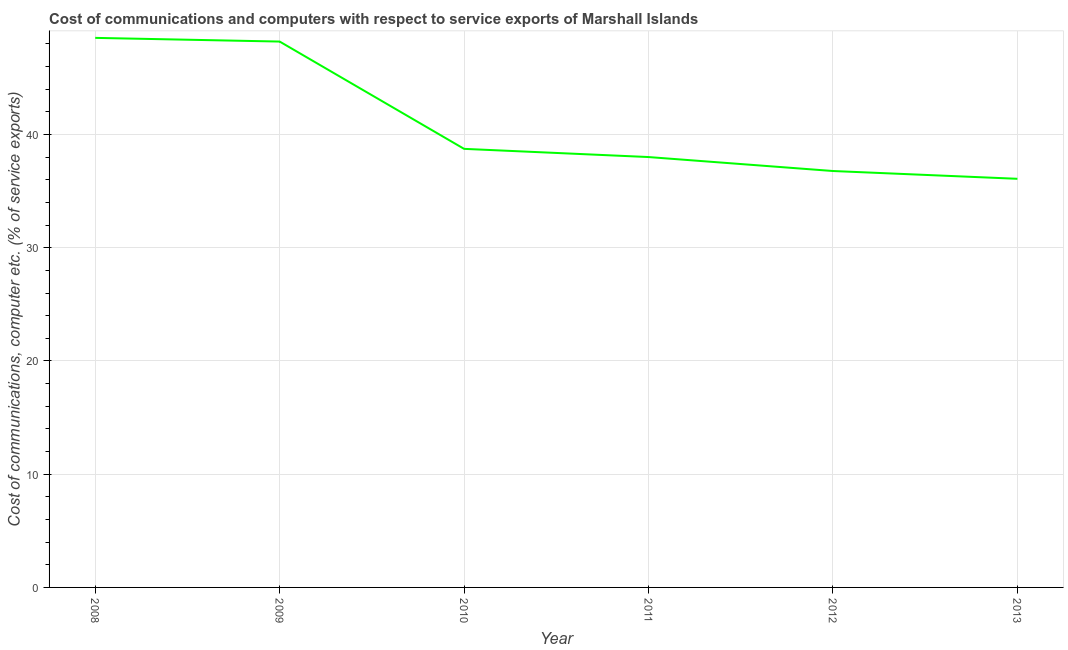What is the cost of communications and computer in 2010?
Provide a short and direct response. 38.73. Across all years, what is the maximum cost of communications and computer?
Offer a very short reply. 48.53. Across all years, what is the minimum cost of communications and computer?
Provide a short and direct response. 36.09. In which year was the cost of communications and computer maximum?
Ensure brevity in your answer.  2008. In which year was the cost of communications and computer minimum?
Your answer should be very brief. 2013. What is the sum of the cost of communications and computer?
Provide a short and direct response. 246.33. What is the difference between the cost of communications and computer in 2008 and 2011?
Ensure brevity in your answer.  10.52. What is the average cost of communications and computer per year?
Your answer should be compact. 41.05. What is the median cost of communications and computer?
Offer a terse response. 38.37. In how many years, is the cost of communications and computer greater than 38 %?
Make the answer very short. 4. What is the ratio of the cost of communications and computer in 2011 to that in 2012?
Keep it short and to the point. 1.03. What is the difference between the highest and the second highest cost of communications and computer?
Give a very brief answer. 0.33. What is the difference between the highest and the lowest cost of communications and computer?
Provide a short and direct response. 12.45. How many lines are there?
Offer a terse response. 1. Are the values on the major ticks of Y-axis written in scientific E-notation?
Offer a very short reply. No. What is the title of the graph?
Provide a short and direct response. Cost of communications and computers with respect to service exports of Marshall Islands. What is the label or title of the Y-axis?
Provide a succinct answer. Cost of communications, computer etc. (% of service exports). What is the Cost of communications, computer etc. (% of service exports) in 2008?
Give a very brief answer. 48.53. What is the Cost of communications, computer etc. (% of service exports) in 2009?
Your answer should be compact. 48.2. What is the Cost of communications, computer etc. (% of service exports) of 2010?
Your answer should be very brief. 38.73. What is the Cost of communications, computer etc. (% of service exports) in 2011?
Give a very brief answer. 38.01. What is the Cost of communications, computer etc. (% of service exports) in 2012?
Offer a very short reply. 36.77. What is the Cost of communications, computer etc. (% of service exports) of 2013?
Offer a terse response. 36.09. What is the difference between the Cost of communications, computer etc. (% of service exports) in 2008 and 2009?
Keep it short and to the point. 0.33. What is the difference between the Cost of communications, computer etc. (% of service exports) in 2008 and 2010?
Keep it short and to the point. 9.8. What is the difference between the Cost of communications, computer etc. (% of service exports) in 2008 and 2011?
Offer a terse response. 10.52. What is the difference between the Cost of communications, computer etc. (% of service exports) in 2008 and 2012?
Make the answer very short. 11.76. What is the difference between the Cost of communications, computer etc. (% of service exports) in 2008 and 2013?
Make the answer very short. 12.45. What is the difference between the Cost of communications, computer etc. (% of service exports) in 2009 and 2010?
Your answer should be compact. 9.48. What is the difference between the Cost of communications, computer etc. (% of service exports) in 2009 and 2011?
Give a very brief answer. 10.2. What is the difference between the Cost of communications, computer etc. (% of service exports) in 2009 and 2012?
Your response must be concise. 11.43. What is the difference between the Cost of communications, computer etc. (% of service exports) in 2009 and 2013?
Offer a terse response. 12.12. What is the difference between the Cost of communications, computer etc. (% of service exports) in 2010 and 2011?
Make the answer very short. 0.72. What is the difference between the Cost of communications, computer etc. (% of service exports) in 2010 and 2012?
Keep it short and to the point. 1.96. What is the difference between the Cost of communications, computer etc. (% of service exports) in 2010 and 2013?
Make the answer very short. 2.64. What is the difference between the Cost of communications, computer etc. (% of service exports) in 2011 and 2012?
Ensure brevity in your answer.  1.23. What is the difference between the Cost of communications, computer etc. (% of service exports) in 2011 and 2013?
Provide a short and direct response. 1.92. What is the difference between the Cost of communications, computer etc. (% of service exports) in 2012 and 2013?
Make the answer very short. 0.69. What is the ratio of the Cost of communications, computer etc. (% of service exports) in 2008 to that in 2009?
Provide a short and direct response. 1.01. What is the ratio of the Cost of communications, computer etc. (% of service exports) in 2008 to that in 2010?
Offer a very short reply. 1.25. What is the ratio of the Cost of communications, computer etc. (% of service exports) in 2008 to that in 2011?
Your answer should be compact. 1.28. What is the ratio of the Cost of communications, computer etc. (% of service exports) in 2008 to that in 2012?
Provide a succinct answer. 1.32. What is the ratio of the Cost of communications, computer etc. (% of service exports) in 2008 to that in 2013?
Make the answer very short. 1.34. What is the ratio of the Cost of communications, computer etc. (% of service exports) in 2009 to that in 2010?
Keep it short and to the point. 1.25. What is the ratio of the Cost of communications, computer etc. (% of service exports) in 2009 to that in 2011?
Provide a short and direct response. 1.27. What is the ratio of the Cost of communications, computer etc. (% of service exports) in 2009 to that in 2012?
Provide a succinct answer. 1.31. What is the ratio of the Cost of communications, computer etc. (% of service exports) in 2009 to that in 2013?
Make the answer very short. 1.34. What is the ratio of the Cost of communications, computer etc. (% of service exports) in 2010 to that in 2012?
Make the answer very short. 1.05. What is the ratio of the Cost of communications, computer etc. (% of service exports) in 2010 to that in 2013?
Make the answer very short. 1.07. What is the ratio of the Cost of communications, computer etc. (% of service exports) in 2011 to that in 2012?
Give a very brief answer. 1.03. What is the ratio of the Cost of communications, computer etc. (% of service exports) in 2011 to that in 2013?
Make the answer very short. 1.05. 